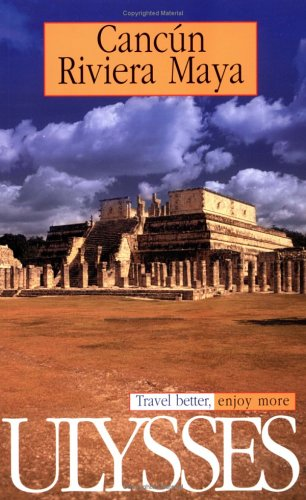What specific attractions or activities might this travel guide recommend in this region? This guide is likely to recommend visiting the famous beaches of Cancun, exploring the ancient ruins like those shown on the cover at Chichen Itza, snorkeling or diving in the cenotes, and experiencing local culture and cuisine. 